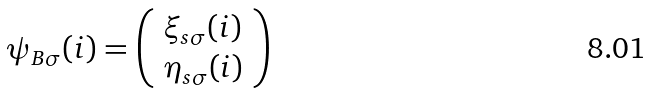Convert formula to latex. <formula><loc_0><loc_0><loc_500><loc_500>\psi _ { B \sigma } ( i ) = \left ( \begin{array} { l } \xi _ { s \sigma } ( i ) \\ \eta _ { s \sigma } ( i ) \end{array} \right )</formula> 